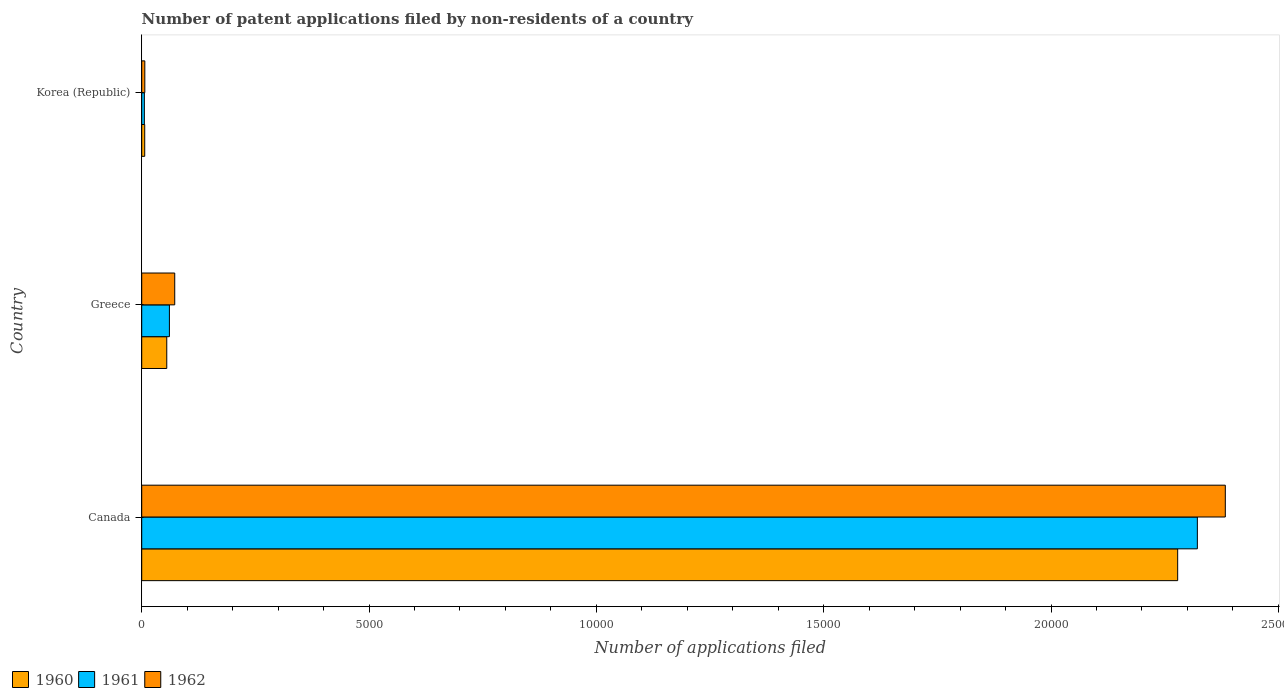How many different coloured bars are there?
Your answer should be compact. 3. Are the number of bars per tick equal to the number of legend labels?
Your response must be concise. Yes. Are the number of bars on each tick of the Y-axis equal?
Provide a short and direct response. Yes. How many bars are there on the 3rd tick from the bottom?
Your answer should be compact. 3. What is the number of applications filed in 1960 in Canada?
Ensure brevity in your answer.  2.28e+04. Across all countries, what is the maximum number of applications filed in 1960?
Ensure brevity in your answer.  2.28e+04. Across all countries, what is the minimum number of applications filed in 1961?
Offer a very short reply. 58. In which country was the number of applications filed in 1961 maximum?
Offer a very short reply. Canada. What is the total number of applications filed in 1961 in the graph?
Ensure brevity in your answer.  2.39e+04. What is the difference between the number of applications filed in 1960 in Canada and that in Greece?
Provide a short and direct response. 2.22e+04. What is the difference between the number of applications filed in 1961 in Greece and the number of applications filed in 1962 in Korea (Republic)?
Your response must be concise. 541. What is the average number of applications filed in 1960 per country?
Provide a succinct answer. 7801. What is the ratio of the number of applications filed in 1962 in Greece to that in Korea (Republic)?
Give a very brief answer. 10.68. Is the number of applications filed in 1961 in Greece less than that in Korea (Republic)?
Ensure brevity in your answer.  No. What is the difference between the highest and the second highest number of applications filed in 1961?
Offer a terse response. 2.26e+04. What is the difference between the highest and the lowest number of applications filed in 1962?
Keep it short and to the point. 2.38e+04. In how many countries, is the number of applications filed in 1962 greater than the average number of applications filed in 1962 taken over all countries?
Your response must be concise. 1. Is the sum of the number of applications filed in 1961 in Canada and Korea (Republic) greater than the maximum number of applications filed in 1960 across all countries?
Provide a short and direct response. Yes. What does the 3rd bar from the top in Korea (Republic) represents?
Offer a terse response. 1960. What does the 3rd bar from the bottom in Greece represents?
Give a very brief answer. 1962. Is it the case that in every country, the sum of the number of applications filed in 1962 and number of applications filed in 1961 is greater than the number of applications filed in 1960?
Provide a succinct answer. Yes. Where does the legend appear in the graph?
Your answer should be very brief. Bottom left. How are the legend labels stacked?
Your response must be concise. Horizontal. What is the title of the graph?
Your answer should be very brief. Number of patent applications filed by non-residents of a country. What is the label or title of the X-axis?
Offer a very short reply. Number of applications filed. What is the Number of applications filed of 1960 in Canada?
Your answer should be very brief. 2.28e+04. What is the Number of applications filed in 1961 in Canada?
Ensure brevity in your answer.  2.32e+04. What is the Number of applications filed in 1962 in Canada?
Ensure brevity in your answer.  2.38e+04. What is the Number of applications filed in 1960 in Greece?
Ensure brevity in your answer.  551. What is the Number of applications filed in 1961 in Greece?
Give a very brief answer. 609. What is the Number of applications filed in 1962 in Greece?
Provide a succinct answer. 726. What is the Number of applications filed in 1960 in Korea (Republic)?
Ensure brevity in your answer.  66. What is the Number of applications filed in 1961 in Korea (Republic)?
Provide a short and direct response. 58. Across all countries, what is the maximum Number of applications filed in 1960?
Your answer should be very brief. 2.28e+04. Across all countries, what is the maximum Number of applications filed in 1961?
Offer a very short reply. 2.32e+04. Across all countries, what is the maximum Number of applications filed of 1962?
Provide a succinct answer. 2.38e+04. What is the total Number of applications filed of 1960 in the graph?
Your answer should be very brief. 2.34e+04. What is the total Number of applications filed of 1961 in the graph?
Your answer should be compact. 2.39e+04. What is the total Number of applications filed in 1962 in the graph?
Give a very brief answer. 2.46e+04. What is the difference between the Number of applications filed of 1960 in Canada and that in Greece?
Ensure brevity in your answer.  2.22e+04. What is the difference between the Number of applications filed in 1961 in Canada and that in Greece?
Offer a terse response. 2.26e+04. What is the difference between the Number of applications filed in 1962 in Canada and that in Greece?
Provide a short and direct response. 2.31e+04. What is the difference between the Number of applications filed of 1960 in Canada and that in Korea (Republic)?
Your answer should be very brief. 2.27e+04. What is the difference between the Number of applications filed of 1961 in Canada and that in Korea (Republic)?
Provide a short and direct response. 2.32e+04. What is the difference between the Number of applications filed in 1962 in Canada and that in Korea (Republic)?
Your answer should be compact. 2.38e+04. What is the difference between the Number of applications filed of 1960 in Greece and that in Korea (Republic)?
Offer a terse response. 485. What is the difference between the Number of applications filed in 1961 in Greece and that in Korea (Republic)?
Your answer should be compact. 551. What is the difference between the Number of applications filed of 1962 in Greece and that in Korea (Republic)?
Provide a short and direct response. 658. What is the difference between the Number of applications filed of 1960 in Canada and the Number of applications filed of 1961 in Greece?
Offer a very short reply. 2.22e+04. What is the difference between the Number of applications filed of 1960 in Canada and the Number of applications filed of 1962 in Greece?
Make the answer very short. 2.21e+04. What is the difference between the Number of applications filed in 1961 in Canada and the Number of applications filed in 1962 in Greece?
Give a very brief answer. 2.25e+04. What is the difference between the Number of applications filed in 1960 in Canada and the Number of applications filed in 1961 in Korea (Republic)?
Your answer should be very brief. 2.27e+04. What is the difference between the Number of applications filed in 1960 in Canada and the Number of applications filed in 1962 in Korea (Republic)?
Provide a short and direct response. 2.27e+04. What is the difference between the Number of applications filed in 1961 in Canada and the Number of applications filed in 1962 in Korea (Republic)?
Keep it short and to the point. 2.32e+04. What is the difference between the Number of applications filed in 1960 in Greece and the Number of applications filed in 1961 in Korea (Republic)?
Your response must be concise. 493. What is the difference between the Number of applications filed of 1960 in Greece and the Number of applications filed of 1962 in Korea (Republic)?
Offer a very short reply. 483. What is the difference between the Number of applications filed in 1961 in Greece and the Number of applications filed in 1962 in Korea (Republic)?
Keep it short and to the point. 541. What is the average Number of applications filed of 1960 per country?
Provide a succinct answer. 7801. What is the average Number of applications filed of 1961 per country?
Provide a succinct answer. 7962. What is the average Number of applications filed of 1962 per country?
Your answer should be very brief. 8209.33. What is the difference between the Number of applications filed in 1960 and Number of applications filed in 1961 in Canada?
Your response must be concise. -433. What is the difference between the Number of applications filed of 1960 and Number of applications filed of 1962 in Canada?
Keep it short and to the point. -1048. What is the difference between the Number of applications filed of 1961 and Number of applications filed of 1962 in Canada?
Give a very brief answer. -615. What is the difference between the Number of applications filed of 1960 and Number of applications filed of 1961 in Greece?
Provide a succinct answer. -58. What is the difference between the Number of applications filed of 1960 and Number of applications filed of 1962 in Greece?
Offer a very short reply. -175. What is the difference between the Number of applications filed in 1961 and Number of applications filed in 1962 in Greece?
Offer a very short reply. -117. What is the difference between the Number of applications filed of 1960 and Number of applications filed of 1961 in Korea (Republic)?
Keep it short and to the point. 8. What is the difference between the Number of applications filed in 1961 and Number of applications filed in 1962 in Korea (Republic)?
Ensure brevity in your answer.  -10. What is the ratio of the Number of applications filed in 1960 in Canada to that in Greece?
Provide a short and direct response. 41.35. What is the ratio of the Number of applications filed of 1961 in Canada to that in Greece?
Your answer should be very brief. 38.13. What is the ratio of the Number of applications filed of 1962 in Canada to that in Greece?
Make the answer very short. 32.83. What is the ratio of the Number of applications filed in 1960 in Canada to that in Korea (Republic)?
Provide a short and direct response. 345.24. What is the ratio of the Number of applications filed in 1961 in Canada to that in Korea (Republic)?
Your response must be concise. 400.33. What is the ratio of the Number of applications filed of 1962 in Canada to that in Korea (Republic)?
Keep it short and to the point. 350.5. What is the ratio of the Number of applications filed in 1960 in Greece to that in Korea (Republic)?
Ensure brevity in your answer.  8.35. What is the ratio of the Number of applications filed of 1961 in Greece to that in Korea (Republic)?
Your answer should be compact. 10.5. What is the ratio of the Number of applications filed of 1962 in Greece to that in Korea (Republic)?
Ensure brevity in your answer.  10.68. What is the difference between the highest and the second highest Number of applications filed in 1960?
Offer a very short reply. 2.22e+04. What is the difference between the highest and the second highest Number of applications filed of 1961?
Make the answer very short. 2.26e+04. What is the difference between the highest and the second highest Number of applications filed of 1962?
Your answer should be compact. 2.31e+04. What is the difference between the highest and the lowest Number of applications filed of 1960?
Your response must be concise. 2.27e+04. What is the difference between the highest and the lowest Number of applications filed of 1961?
Give a very brief answer. 2.32e+04. What is the difference between the highest and the lowest Number of applications filed of 1962?
Make the answer very short. 2.38e+04. 